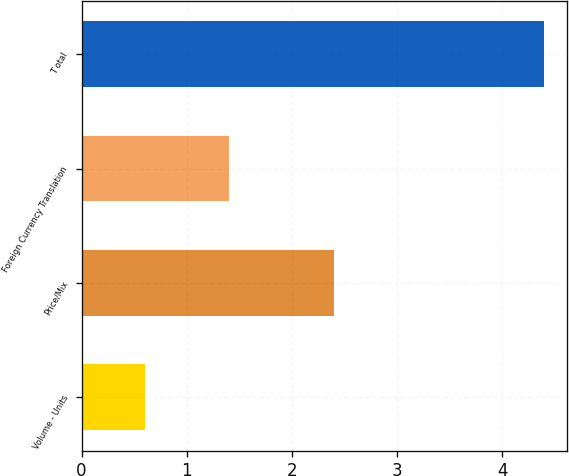Convert chart to OTSL. <chart><loc_0><loc_0><loc_500><loc_500><bar_chart><fcel>Volume - Units<fcel>Price/Mix<fcel>Foreign Currency Translation<fcel>T otal<nl><fcel>0.6<fcel>2.4<fcel>1.4<fcel>4.4<nl></chart> 